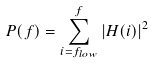Convert formula to latex. <formula><loc_0><loc_0><loc_500><loc_500>P ( f ) = \sum _ { i = f _ { l o w } } ^ { f } | H ( i ) | ^ { 2 }</formula> 